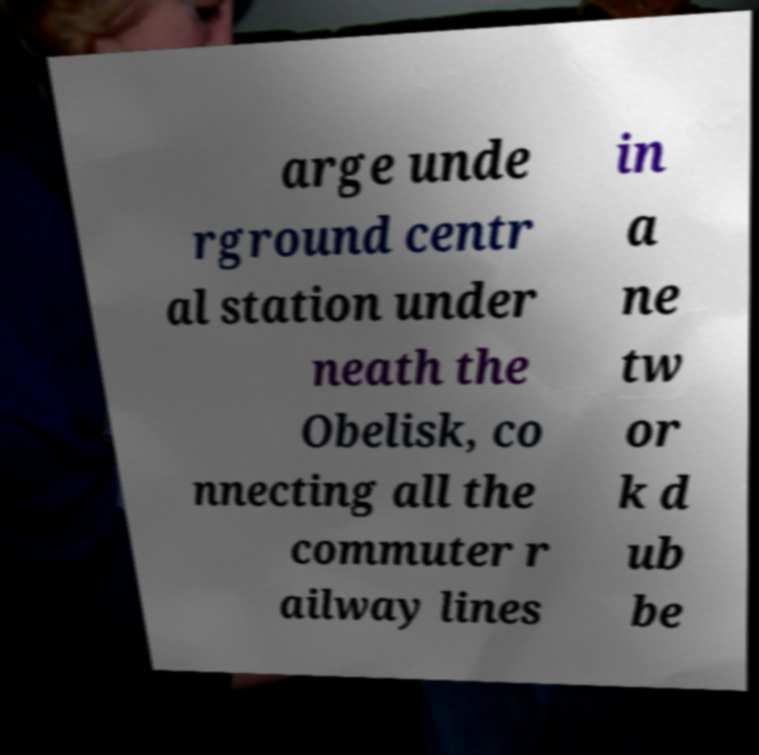Could you extract and type out the text from this image? arge unde rground centr al station under neath the Obelisk, co nnecting all the commuter r ailway lines in a ne tw or k d ub be 